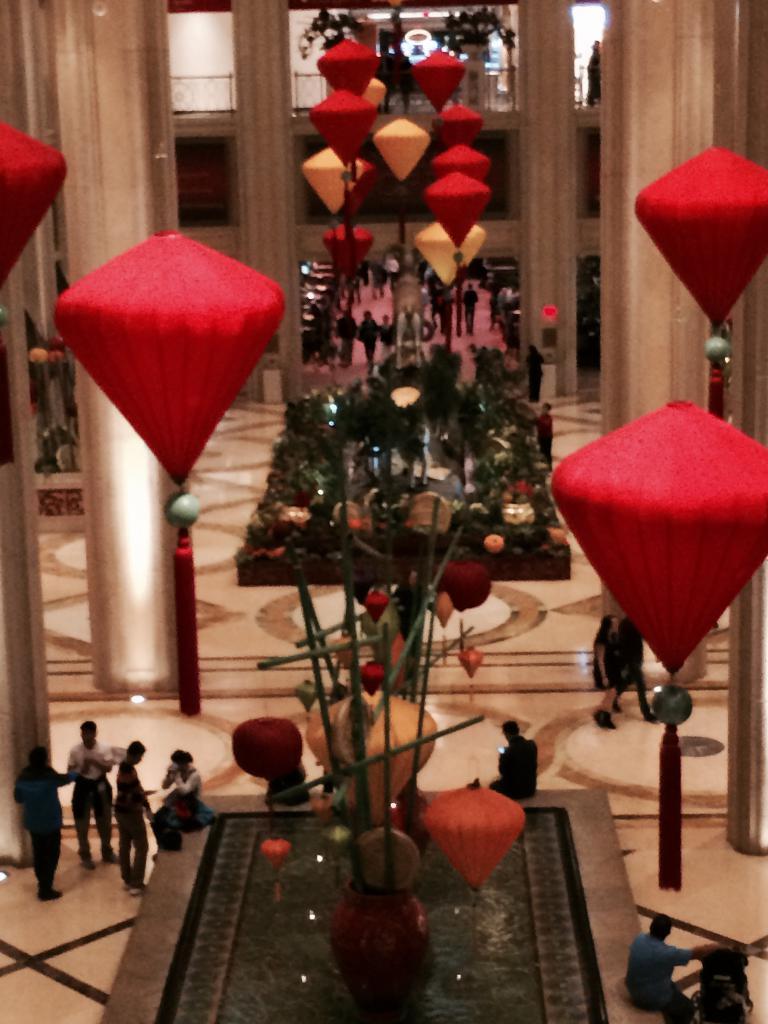In one or two sentences, can you explain what this image depicts? In the picture there is a huge hall, there are pillars and there are few people around the pillars, there are some decorations hanged to the roof. 